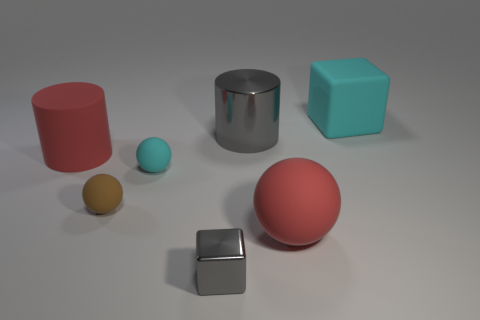Do the gray cube that is in front of the cyan rubber sphere and the large gray object have the same material? yes 